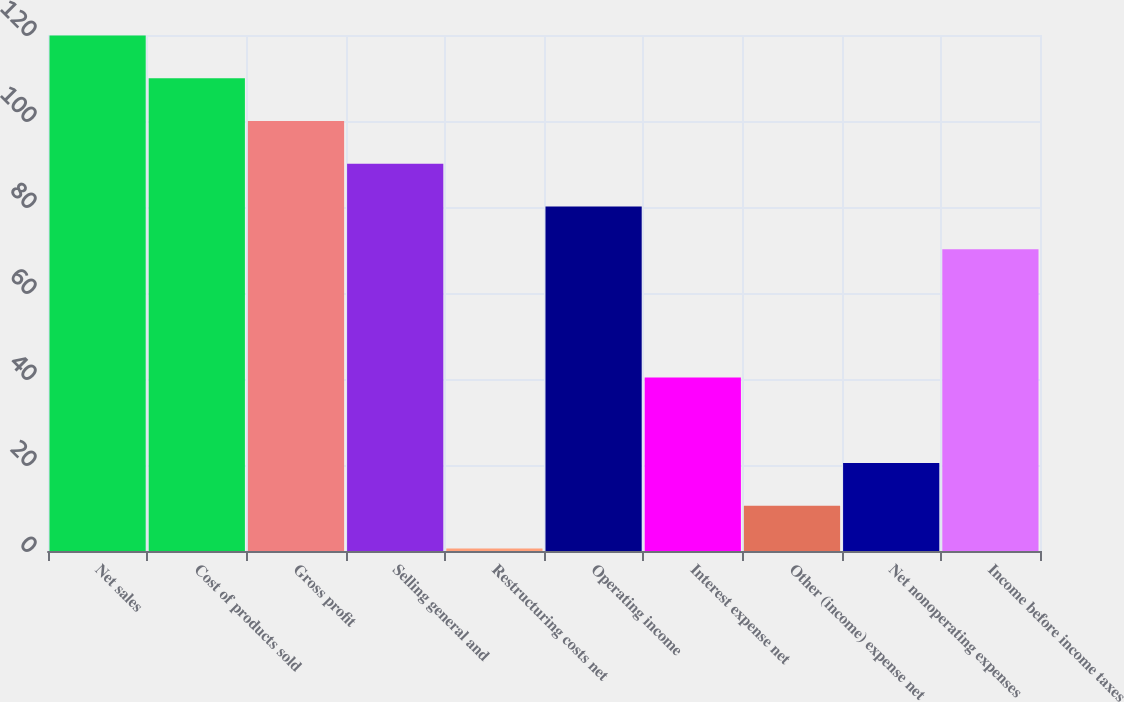<chart> <loc_0><loc_0><loc_500><loc_500><bar_chart><fcel>Net sales<fcel>Cost of products sold<fcel>Gross profit<fcel>Selling general and<fcel>Restructuring costs net<fcel>Operating income<fcel>Interest expense net<fcel>Other (income) expense net<fcel>Net nonoperating expenses<fcel>Income before income taxes<nl><fcel>119.88<fcel>109.94<fcel>100<fcel>90.06<fcel>0.6<fcel>80.12<fcel>40.36<fcel>10.54<fcel>20.48<fcel>70.18<nl></chart> 